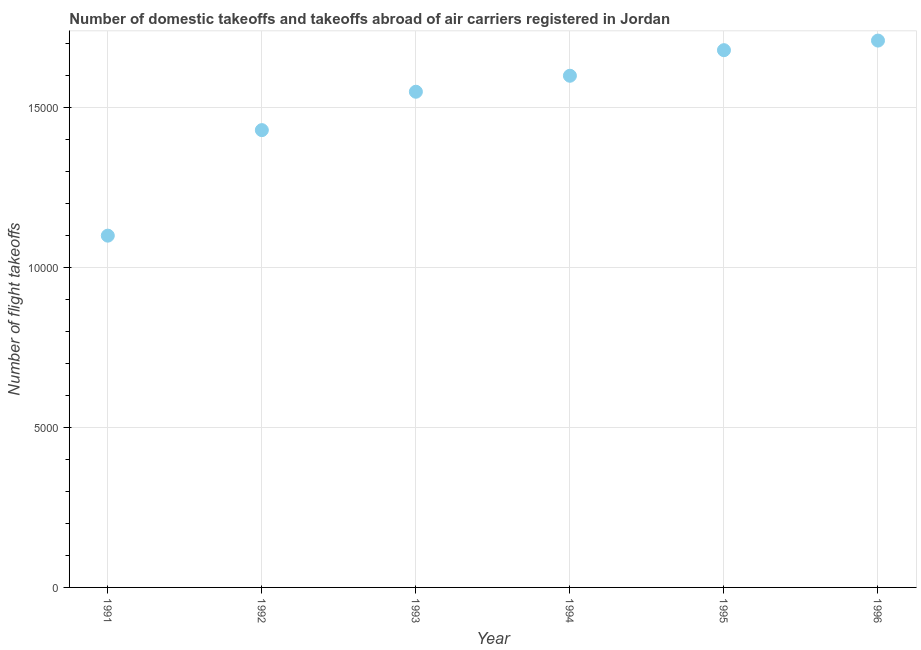What is the number of flight takeoffs in 1992?
Give a very brief answer. 1.43e+04. Across all years, what is the maximum number of flight takeoffs?
Ensure brevity in your answer.  1.71e+04. Across all years, what is the minimum number of flight takeoffs?
Offer a terse response. 1.10e+04. In which year was the number of flight takeoffs maximum?
Ensure brevity in your answer.  1996. What is the sum of the number of flight takeoffs?
Your response must be concise. 9.07e+04. What is the difference between the number of flight takeoffs in 1992 and 1996?
Your answer should be compact. -2800. What is the average number of flight takeoffs per year?
Your answer should be compact. 1.51e+04. What is the median number of flight takeoffs?
Your answer should be very brief. 1.58e+04. In how many years, is the number of flight takeoffs greater than 15000 ?
Your response must be concise. 4. What is the ratio of the number of flight takeoffs in 1993 to that in 1995?
Give a very brief answer. 0.92. Is the difference between the number of flight takeoffs in 1991 and 1995 greater than the difference between any two years?
Make the answer very short. No. What is the difference between the highest and the second highest number of flight takeoffs?
Give a very brief answer. 300. What is the difference between the highest and the lowest number of flight takeoffs?
Ensure brevity in your answer.  6100. In how many years, is the number of flight takeoffs greater than the average number of flight takeoffs taken over all years?
Ensure brevity in your answer.  4. Does the number of flight takeoffs monotonically increase over the years?
Provide a succinct answer. Yes. How many years are there in the graph?
Your answer should be compact. 6. Are the values on the major ticks of Y-axis written in scientific E-notation?
Provide a succinct answer. No. Does the graph contain any zero values?
Your answer should be very brief. No. Does the graph contain grids?
Your answer should be very brief. Yes. What is the title of the graph?
Keep it short and to the point. Number of domestic takeoffs and takeoffs abroad of air carriers registered in Jordan. What is the label or title of the Y-axis?
Ensure brevity in your answer.  Number of flight takeoffs. What is the Number of flight takeoffs in 1991?
Offer a terse response. 1.10e+04. What is the Number of flight takeoffs in 1992?
Provide a succinct answer. 1.43e+04. What is the Number of flight takeoffs in 1993?
Make the answer very short. 1.55e+04. What is the Number of flight takeoffs in 1994?
Provide a short and direct response. 1.60e+04. What is the Number of flight takeoffs in 1995?
Give a very brief answer. 1.68e+04. What is the Number of flight takeoffs in 1996?
Offer a very short reply. 1.71e+04. What is the difference between the Number of flight takeoffs in 1991 and 1992?
Your answer should be compact. -3300. What is the difference between the Number of flight takeoffs in 1991 and 1993?
Provide a succinct answer. -4500. What is the difference between the Number of flight takeoffs in 1991 and 1994?
Keep it short and to the point. -5000. What is the difference between the Number of flight takeoffs in 1991 and 1995?
Your answer should be very brief. -5800. What is the difference between the Number of flight takeoffs in 1991 and 1996?
Make the answer very short. -6100. What is the difference between the Number of flight takeoffs in 1992 and 1993?
Offer a terse response. -1200. What is the difference between the Number of flight takeoffs in 1992 and 1994?
Make the answer very short. -1700. What is the difference between the Number of flight takeoffs in 1992 and 1995?
Your answer should be very brief. -2500. What is the difference between the Number of flight takeoffs in 1992 and 1996?
Provide a succinct answer. -2800. What is the difference between the Number of flight takeoffs in 1993 and 1994?
Keep it short and to the point. -500. What is the difference between the Number of flight takeoffs in 1993 and 1995?
Offer a terse response. -1300. What is the difference between the Number of flight takeoffs in 1993 and 1996?
Give a very brief answer. -1600. What is the difference between the Number of flight takeoffs in 1994 and 1995?
Your response must be concise. -800. What is the difference between the Number of flight takeoffs in 1994 and 1996?
Provide a short and direct response. -1100. What is the difference between the Number of flight takeoffs in 1995 and 1996?
Provide a succinct answer. -300. What is the ratio of the Number of flight takeoffs in 1991 to that in 1992?
Give a very brief answer. 0.77. What is the ratio of the Number of flight takeoffs in 1991 to that in 1993?
Ensure brevity in your answer.  0.71. What is the ratio of the Number of flight takeoffs in 1991 to that in 1994?
Your answer should be compact. 0.69. What is the ratio of the Number of flight takeoffs in 1991 to that in 1995?
Provide a succinct answer. 0.66. What is the ratio of the Number of flight takeoffs in 1991 to that in 1996?
Give a very brief answer. 0.64. What is the ratio of the Number of flight takeoffs in 1992 to that in 1993?
Provide a succinct answer. 0.92. What is the ratio of the Number of flight takeoffs in 1992 to that in 1994?
Provide a succinct answer. 0.89. What is the ratio of the Number of flight takeoffs in 1992 to that in 1995?
Provide a succinct answer. 0.85. What is the ratio of the Number of flight takeoffs in 1992 to that in 1996?
Make the answer very short. 0.84. What is the ratio of the Number of flight takeoffs in 1993 to that in 1995?
Your answer should be very brief. 0.92. What is the ratio of the Number of flight takeoffs in 1993 to that in 1996?
Offer a terse response. 0.91. What is the ratio of the Number of flight takeoffs in 1994 to that in 1996?
Keep it short and to the point. 0.94. 